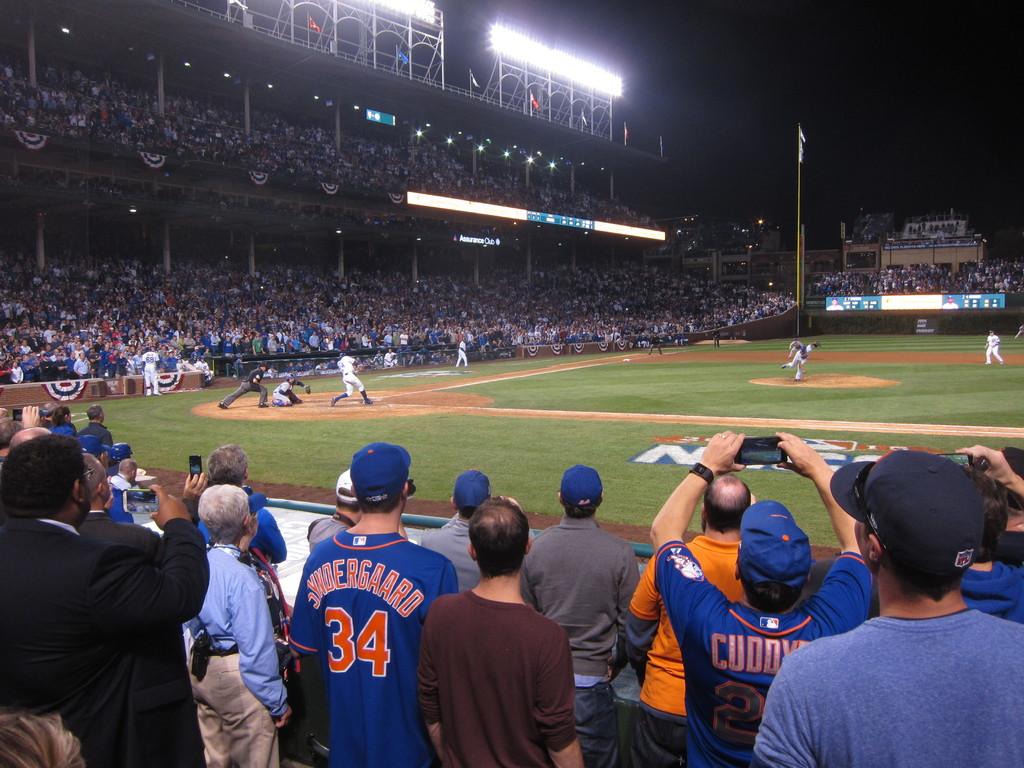What number jersey is the man wearing?
Give a very brief answer. 34. Does the jersey to the right start with the number 2?
Your response must be concise. Yes. 